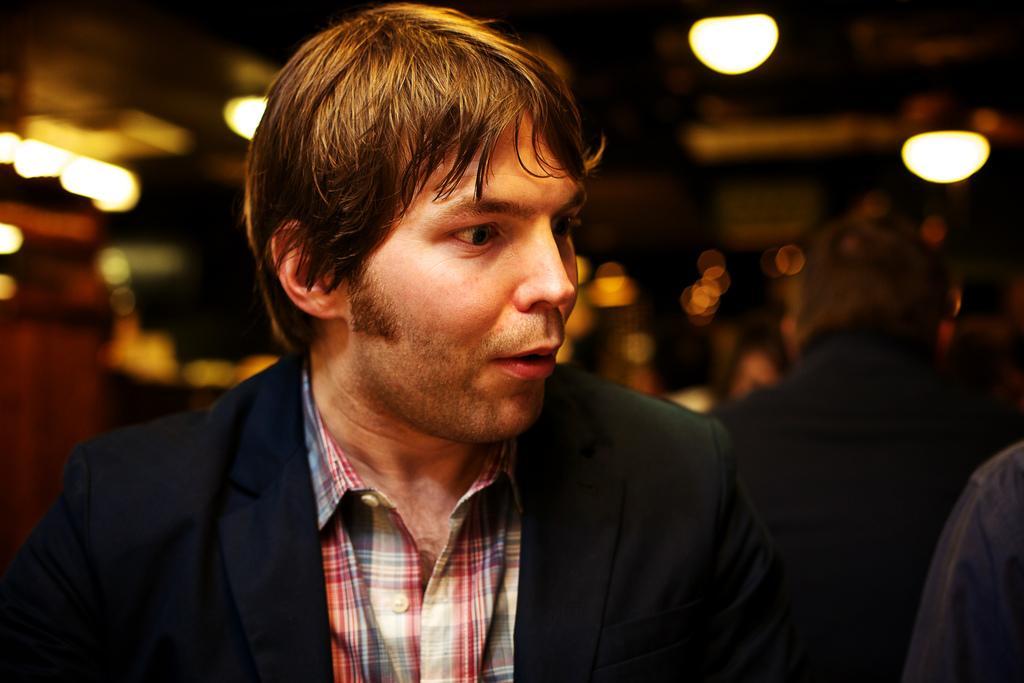Can you describe this image briefly? In this image we can see a man wearing the suit. We can also see the other people. The background is blurred and we can also see the lights. 